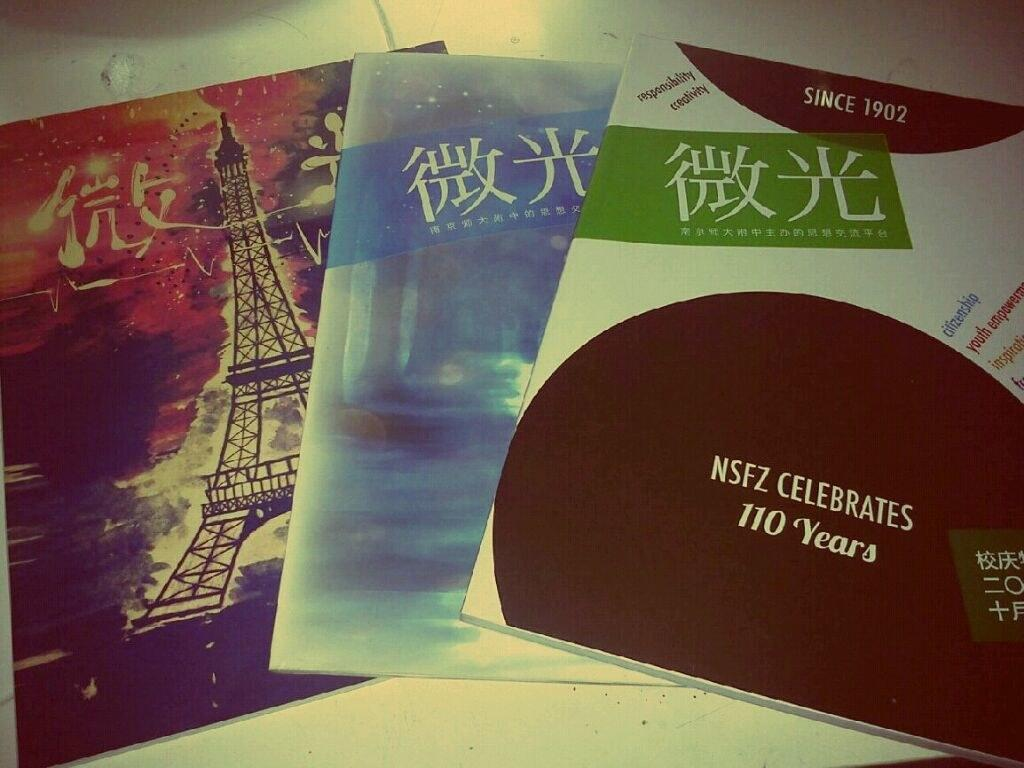<image>
Describe the image concisely. Placards stating that NSFZ is celebrating 110 years in business. 